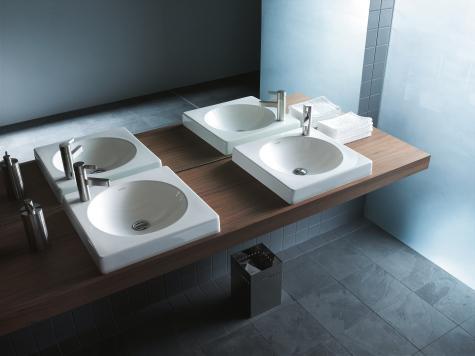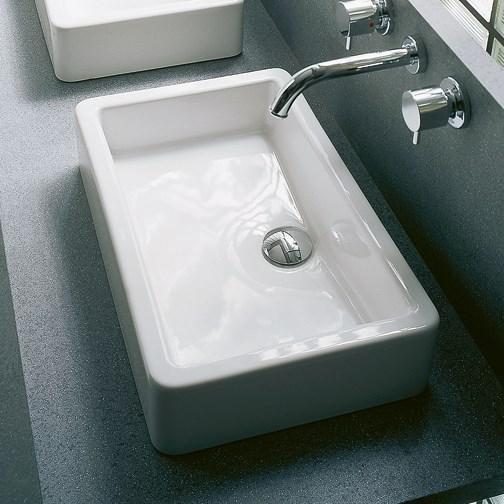The first image is the image on the left, the second image is the image on the right. Given the left and right images, does the statement "The left image features at least one round sink inset in white and mounted on the wall, and the right image features a rectangular white sink." hold true? Answer yes or no. Yes. The first image is the image on the left, the second image is the image on the right. Analyze the images presented: Is the assertion "There is a mirror positioned above every sink basin." valid? Answer yes or no. No. 